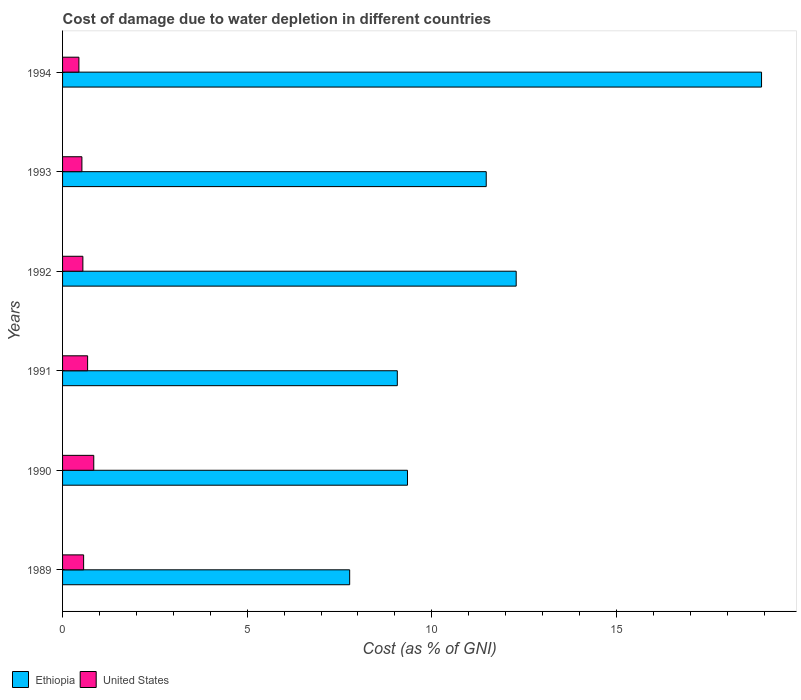How many groups of bars are there?
Your response must be concise. 6. How many bars are there on the 5th tick from the top?
Offer a very short reply. 2. How many bars are there on the 6th tick from the bottom?
Your answer should be compact. 2. What is the label of the 1st group of bars from the top?
Provide a short and direct response. 1994. What is the cost of damage caused due to water depletion in Ethiopia in 1991?
Your answer should be compact. 9.07. Across all years, what is the maximum cost of damage caused due to water depletion in Ethiopia?
Keep it short and to the point. 18.93. Across all years, what is the minimum cost of damage caused due to water depletion in United States?
Offer a terse response. 0.44. In which year was the cost of damage caused due to water depletion in Ethiopia minimum?
Offer a very short reply. 1989. What is the total cost of damage caused due to water depletion in United States in the graph?
Provide a short and direct response. 3.61. What is the difference between the cost of damage caused due to water depletion in United States in 1990 and that in 1991?
Give a very brief answer. 0.17. What is the difference between the cost of damage caused due to water depletion in United States in 1993 and the cost of damage caused due to water depletion in Ethiopia in 1991?
Provide a succinct answer. -8.54. What is the average cost of damage caused due to water depletion in United States per year?
Offer a very short reply. 0.6. In the year 1989, what is the difference between the cost of damage caused due to water depletion in Ethiopia and cost of damage caused due to water depletion in United States?
Ensure brevity in your answer.  7.21. In how many years, is the cost of damage caused due to water depletion in United States greater than 15 %?
Ensure brevity in your answer.  0. What is the ratio of the cost of damage caused due to water depletion in United States in 1989 to that in 1993?
Provide a succinct answer. 1.09. Is the difference between the cost of damage caused due to water depletion in Ethiopia in 1991 and 1993 greater than the difference between the cost of damage caused due to water depletion in United States in 1991 and 1993?
Ensure brevity in your answer.  No. What is the difference between the highest and the second highest cost of damage caused due to water depletion in United States?
Offer a terse response. 0.17. What is the difference between the highest and the lowest cost of damage caused due to water depletion in United States?
Offer a terse response. 0.4. Is the sum of the cost of damage caused due to water depletion in Ethiopia in 1990 and 1993 greater than the maximum cost of damage caused due to water depletion in United States across all years?
Give a very brief answer. Yes. What does the 2nd bar from the top in 1989 represents?
Your response must be concise. Ethiopia. Are all the bars in the graph horizontal?
Provide a short and direct response. Yes. Are the values on the major ticks of X-axis written in scientific E-notation?
Provide a short and direct response. No. Does the graph contain any zero values?
Keep it short and to the point. No. Does the graph contain grids?
Provide a short and direct response. No. How many legend labels are there?
Keep it short and to the point. 2. How are the legend labels stacked?
Provide a succinct answer. Horizontal. What is the title of the graph?
Ensure brevity in your answer.  Cost of damage due to water depletion in different countries. What is the label or title of the X-axis?
Make the answer very short. Cost (as % of GNI). What is the Cost (as % of GNI) of Ethiopia in 1989?
Ensure brevity in your answer.  7.78. What is the Cost (as % of GNI) in United States in 1989?
Provide a succinct answer. 0.57. What is the Cost (as % of GNI) of Ethiopia in 1990?
Ensure brevity in your answer.  9.34. What is the Cost (as % of GNI) in United States in 1990?
Provide a succinct answer. 0.85. What is the Cost (as % of GNI) of Ethiopia in 1991?
Give a very brief answer. 9.07. What is the Cost (as % of GNI) of United States in 1991?
Your answer should be compact. 0.68. What is the Cost (as % of GNI) in Ethiopia in 1992?
Make the answer very short. 12.29. What is the Cost (as % of GNI) of United States in 1992?
Give a very brief answer. 0.55. What is the Cost (as % of GNI) in Ethiopia in 1993?
Ensure brevity in your answer.  11.47. What is the Cost (as % of GNI) of United States in 1993?
Your answer should be compact. 0.52. What is the Cost (as % of GNI) in Ethiopia in 1994?
Give a very brief answer. 18.93. What is the Cost (as % of GNI) in United States in 1994?
Your answer should be very brief. 0.44. Across all years, what is the maximum Cost (as % of GNI) in Ethiopia?
Your answer should be very brief. 18.93. Across all years, what is the maximum Cost (as % of GNI) in United States?
Your response must be concise. 0.85. Across all years, what is the minimum Cost (as % of GNI) of Ethiopia?
Your answer should be compact. 7.78. Across all years, what is the minimum Cost (as % of GNI) of United States?
Make the answer very short. 0.44. What is the total Cost (as % of GNI) of Ethiopia in the graph?
Keep it short and to the point. 68.88. What is the total Cost (as % of GNI) in United States in the graph?
Give a very brief answer. 3.61. What is the difference between the Cost (as % of GNI) of Ethiopia in 1989 and that in 1990?
Your answer should be compact. -1.57. What is the difference between the Cost (as % of GNI) in United States in 1989 and that in 1990?
Your answer should be very brief. -0.27. What is the difference between the Cost (as % of GNI) of Ethiopia in 1989 and that in 1991?
Offer a very short reply. -1.29. What is the difference between the Cost (as % of GNI) in United States in 1989 and that in 1991?
Make the answer very short. -0.11. What is the difference between the Cost (as % of GNI) in Ethiopia in 1989 and that in 1992?
Give a very brief answer. -4.51. What is the difference between the Cost (as % of GNI) of United States in 1989 and that in 1992?
Offer a terse response. 0.02. What is the difference between the Cost (as % of GNI) in Ethiopia in 1989 and that in 1993?
Ensure brevity in your answer.  -3.7. What is the difference between the Cost (as % of GNI) of United States in 1989 and that in 1993?
Offer a terse response. 0.05. What is the difference between the Cost (as % of GNI) of Ethiopia in 1989 and that in 1994?
Make the answer very short. -11.16. What is the difference between the Cost (as % of GNI) in United States in 1989 and that in 1994?
Offer a very short reply. 0.13. What is the difference between the Cost (as % of GNI) in Ethiopia in 1990 and that in 1991?
Give a very brief answer. 0.28. What is the difference between the Cost (as % of GNI) in United States in 1990 and that in 1991?
Keep it short and to the point. 0.17. What is the difference between the Cost (as % of GNI) in Ethiopia in 1990 and that in 1992?
Give a very brief answer. -2.94. What is the difference between the Cost (as % of GNI) of United States in 1990 and that in 1992?
Give a very brief answer. 0.29. What is the difference between the Cost (as % of GNI) of Ethiopia in 1990 and that in 1993?
Provide a succinct answer. -2.13. What is the difference between the Cost (as % of GNI) in United States in 1990 and that in 1993?
Your answer should be very brief. 0.32. What is the difference between the Cost (as % of GNI) of Ethiopia in 1990 and that in 1994?
Ensure brevity in your answer.  -9.59. What is the difference between the Cost (as % of GNI) of United States in 1990 and that in 1994?
Provide a short and direct response. 0.4. What is the difference between the Cost (as % of GNI) of Ethiopia in 1991 and that in 1992?
Your answer should be compact. -3.22. What is the difference between the Cost (as % of GNI) of United States in 1991 and that in 1992?
Your response must be concise. 0.13. What is the difference between the Cost (as % of GNI) in Ethiopia in 1991 and that in 1993?
Keep it short and to the point. -2.41. What is the difference between the Cost (as % of GNI) in United States in 1991 and that in 1993?
Your response must be concise. 0.15. What is the difference between the Cost (as % of GNI) in Ethiopia in 1991 and that in 1994?
Offer a terse response. -9.86. What is the difference between the Cost (as % of GNI) of United States in 1991 and that in 1994?
Your answer should be compact. 0.24. What is the difference between the Cost (as % of GNI) in Ethiopia in 1992 and that in 1993?
Offer a very short reply. 0.81. What is the difference between the Cost (as % of GNI) of United States in 1992 and that in 1993?
Your answer should be compact. 0.03. What is the difference between the Cost (as % of GNI) of Ethiopia in 1992 and that in 1994?
Offer a terse response. -6.65. What is the difference between the Cost (as % of GNI) of United States in 1992 and that in 1994?
Offer a very short reply. 0.11. What is the difference between the Cost (as % of GNI) in Ethiopia in 1993 and that in 1994?
Provide a succinct answer. -7.46. What is the difference between the Cost (as % of GNI) of United States in 1993 and that in 1994?
Give a very brief answer. 0.08. What is the difference between the Cost (as % of GNI) of Ethiopia in 1989 and the Cost (as % of GNI) of United States in 1990?
Make the answer very short. 6.93. What is the difference between the Cost (as % of GNI) of Ethiopia in 1989 and the Cost (as % of GNI) of United States in 1991?
Provide a short and direct response. 7.1. What is the difference between the Cost (as % of GNI) of Ethiopia in 1989 and the Cost (as % of GNI) of United States in 1992?
Offer a very short reply. 7.23. What is the difference between the Cost (as % of GNI) of Ethiopia in 1989 and the Cost (as % of GNI) of United States in 1993?
Your answer should be compact. 7.25. What is the difference between the Cost (as % of GNI) of Ethiopia in 1989 and the Cost (as % of GNI) of United States in 1994?
Ensure brevity in your answer.  7.33. What is the difference between the Cost (as % of GNI) in Ethiopia in 1990 and the Cost (as % of GNI) in United States in 1991?
Provide a succinct answer. 8.66. What is the difference between the Cost (as % of GNI) of Ethiopia in 1990 and the Cost (as % of GNI) of United States in 1992?
Your response must be concise. 8.79. What is the difference between the Cost (as % of GNI) of Ethiopia in 1990 and the Cost (as % of GNI) of United States in 1993?
Your response must be concise. 8.82. What is the difference between the Cost (as % of GNI) of Ethiopia in 1990 and the Cost (as % of GNI) of United States in 1994?
Ensure brevity in your answer.  8.9. What is the difference between the Cost (as % of GNI) of Ethiopia in 1991 and the Cost (as % of GNI) of United States in 1992?
Your answer should be compact. 8.52. What is the difference between the Cost (as % of GNI) of Ethiopia in 1991 and the Cost (as % of GNI) of United States in 1993?
Offer a very short reply. 8.54. What is the difference between the Cost (as % of GNI) of Ethiopia in 1991 and the Cost (as % of GNI) of United States in 1994?
Offer a very short reply. 8.62. What is the difference between the Cost (as % of GNI) of Ethiopia in 1992 and the Cost (as % of GNI) of United States in 1993?
Keep it short and to the point. 11.76. What is the difference between the Cost (as % of GNI) of Ethiopia in 1992 and the Cost (as % of GNI) of United States in 1994?
Keep it short and to the point. 11.84. What is the difference between the Cost (as % of GNI) in Ethiopia in 1993 and the Cost (as % of GNI) in United States in 1994?
Provide a succinct answer. 11.03. What is the average Cost (as % of GNI) in Ethiopia per year?
Your answer should be very brief. 11.48. What is the average Cost (as % of GNI) in United States per year?
Keep it short and to the point. 0.6. In the year 1989, what is the difference between the Cost (as % of GNI) in Ethiopia and Cost (as % of GNI) in United States?
Your answer should be very brief. 7.21. In the year 1990, what is the difference between the Cost (as % of GNI) of Ethiopia and Cost (as % of GNI) of United States?
Provide a short and direct response. 8.5. In the year 1991, what is the difference between the Cost (as % of GNI) of Ethiopia and Cost (as % of GNI) of United States?
Make the answer very short. 8.39. In the year 1992, what is the difference between the Cost (as % of GNI) of Ethiopia and Cost (as % of GNI) of United States?
Provide a succinct answer. 11.74. In the year 1993, what is the difference between the Cost (as % of GNI) of Ethiopia and Cost (as % of GNI) of United States?
Keep it short and to the point. 10.95. In the year 1994, what is the difference between the Cost (as % of GNI) in Ethiopia and Cost (as % of GNI) in United States?
Offer a very short reply. 18.49. What is the ratio of the Cost (as % of GNI) of Ethiopia in 1989 to that in 1990?
Offer a very short reply. 0.83. What is the ratio of the Cost (as % of GNI) of United States in 1989 to that in 1990?
Provide a succinct answer. 0.67. What is the ratio of the Cost (as % of GNI) of Ethiopia in 1989 to that in 1991?
Your response must be concise. 0.86. What is the ratio of the Cost (as % of GNI) of United States in 1989 to that in 1991?
Provide a short and direct response. 0.84. What is the ratio of the Cost (as % of GNI) in Ethiopia in 1989 to that in 1992?
Provide a short and direct response. 0.63. What is the ratio of the Cost (as % of GNI) in United States in 1989 to that in 1992?
Keep it short and to the point. 1.04. What is the ratio of the Cost (as % of GNI) in Ethiopia in 1989 to that in 1993?
Give a very brief answer. 0.68. What is the ratio of the Cost (as % of GNI) of United States in 1989 to that in 1993?
Keep it short and to the point. 1.09. What is the ratio of the Cost (as % of GNI) of Ethiopia in 1989 to that in 1994?
Provide a short and direct response. 0.41. What is the ratio of the Cost (as % of GNI) of United States in 1989 to that in 1994?
Offer a very short reply. 1.29. What is the ratio of the Cost (as % of GNI) in Ethiopia in 1990 to that in 1991?
Your response must be concise. 1.03. What is the ratio of the Cost (as % of GNI) of United States in 1990 to that in 1991?
Offer a very short reply. 1.25. What is the ratio of the Cost (as % of GNI) of Ethiopia in 1990 to that in 1992?
Make the answer very short. 0.76. What is the ratio of the Cost (as % of GNI) of United States in 1990 to that in 1992?
Provide a succinct answer. 1.54. What is the ratio of the Cost (as % of GNI) of Ethiopia in 1990 to that in 1993?
Give a very brief answer. 0.81. What is the ratio of the Cost (as % of GNI) in United States in 1990 to that in 1993?
Your answer should be very brief. 1.61. What is the ratio of the Cost (as % of GNI) in Ethiopia in 1990 to that in 1994?
Ensure brevity in your answer.  0.49. What is the ratio of the Cost (as % of GNI) of United States in 1990 to that in 1994?
Keep it short and to the point. 1.91. What is the ratio of the Cost (as % of GNI) of Ethiopia in 1991 to that in 1992?
Make the answer very short. 0.74. What is the ratio of the Cost (as % of GNI) in United States in 1991 to that in 1992?
Your answer should be compact. 1.23. What is the ratio of the Cost (as % of GNI) of Ethiopia in 1991 to that in 1993?
Give a very brief answer. 0.79. What is the ratio of the Cost (as % of GNI) of United States in 1991 to that in 1993?
Ensure brevity in your answer.  1.29. What is the ratio of the Cost (as % of GNI) of Ethiopia in 1991 to that in 1994?
Provide a succinct answer. 0.48. What is the ratio of the Cost (as % of GNI) of United States in 1991 to that in 1994?
Offer a terse response. 1.53. What is the ratio of the Cost (as % of GNI) in Ethiopia in 1992 to that in 1993?
Make the answer very short. 1.07. What is the ratio of the Cost (as % of GNI) in United States in 1992 to that in 1993?
Your answer should be very brief. 1.05. What is the ratio of the Cost (as % of GNI) in Ethiopia in 1992 to that in 1994?
Provide a succinct answer. 0.65. What is the ratio of the Cost (as % of GNI) in United States in 1992 to that in 1994?
Your response must be concise. 1.24. What is the ratio of the Cost (as % of GNI) in Ethiopia in 1993 to that in 1994?
Keep it short and to the point. 0.61. What is the ratio of the Cost (as % of GNI) of United States in 1993 to that in 1994?
Offer a very short reply. 1.18. What is the difference between the highest and the second highest Cost (as % of GNI) of Ethiopia?
Offer a terse response. 6.65. What is the difference between the highest and the second highest Cost (as % of GNI) in United States?
Provide a succinct answer. 0.17. What is the difference between the highest and the lowest Cost (as % of GNI) in Ethiopia?
Provide a short and direct response. 11.16. What is the difference between the highest and the lowest Cost (as % of GNI) of United States?
Your response must be concise. 0.4. 